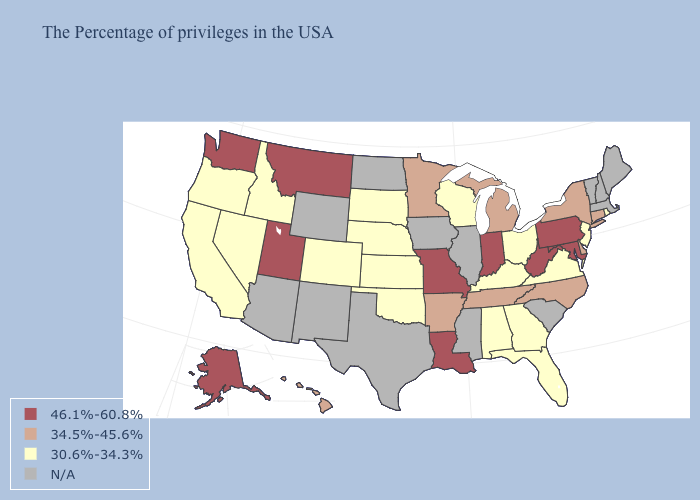What is the lowest value in states that border Montana?
Answer briefly. 30.6%-34.3%. Name the states that have a value in the range 30.6%-34.3%?
Short answer required. Rhode Island, New Jersey, Virginia, Ohio, Florida, Georgia, Kentucky, Alabama, Wisconsin, Kansas, Nebraska, Oklahoma, South Dakota, Colorado, Idaho, Nevada, California, Oregon. Name the states that have a value in the range N/A?
Concise answer only. Maine, Massachusetts, New Hampshire, Vermont, South Carolina, Illinois, Mississippi, Iowa, Texas, North Dakota, Wyoming, New Mexico, Arizona. How many symbols are there in the legend?
Write a very short answer. 4. What is the value of Tennessee?
Write a very short answer. 34.5%-45.6%. Does Pennsylvania have the highest value in the Northeast?
Answer briefly. Yes. Among the states that border Alabama , does Tennessee have the lowest value?
Quick response, please. No. What is the value of North Carolina?
Give a very brief answer. 34.5%-45.6%. What is the value of Utah?
Short answer required. 46.1%-60.8%. What is the value of Maine?
Short answer required. N/A. Is the legend a continuous bar?
Concise answer only. No. Among the states that border Colorado , which have the lowest value?
Keep it brief. Kansas, Nebraska, Oklahoma. Name the states that have a value in the range N/A?
Keep it brief. Maine, Massachusetts, New Hampshire, Vermont, South Carolina, Illinois, Mississippi, Iowa, Texas, North Dakota, Wyoming, New Mexico, Arizona. 